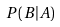Convert formula to latex. <formula><loc_0><loc_0><loc_500><loc_500>P ( B | A )</formula> 